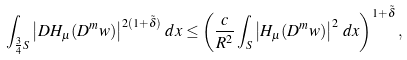<formula> <loc_0><loc_0><loc_500><loc_500>\int _ { \frac { 3 } { 4 } S } \left | D H _ { \mu } ( D ^ { m } w ) \right | ^ { 2 ( 1 + \tilde { \delta } ) } \, d x \leq \left ( \frac { c } { R ^ { 2 } } \int _ { S } \left | H _ { \mu } ( D ^ { m } w ) \right | ^ { 2 } \, d x \right ) ^ { 1 + \tilde { \delta } } ,</formula> 